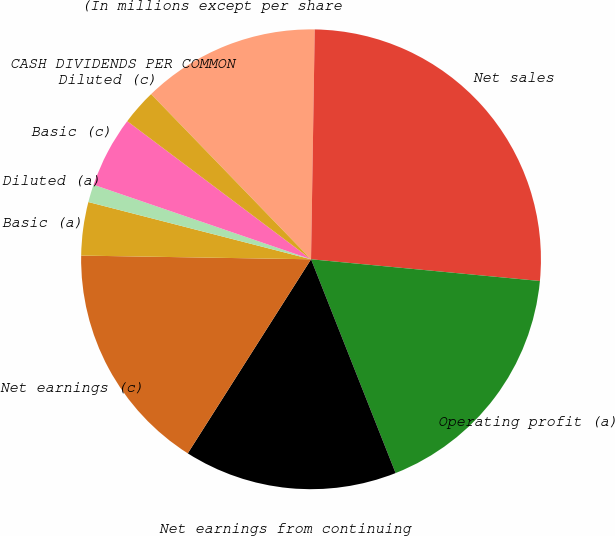Convert chart. <chart><loc_0><loc_0><loc_500><loc_500><pie_chart><fcel>(In millions except per share<fcel>Net sales<fcel>Operating profit (a)<fcel>Net earnings from continuing<fcel>Net earnings (c)<fcel>Basic (a)<fcel>Diluted (a)<fcel>Basic (c)<fcel>Diluted (c)<fcel>CASH DIVIDENDS PER COMMON<nl><fcel>12.5%<fcel>26.25%<fcel>17.5%<fcel>15.0%<fcel>16.25%<fcel>3.75%<fcel>1.25%<fcel>5.0%<fcel>2.5%<fcel>0.0%<nl></chart> 